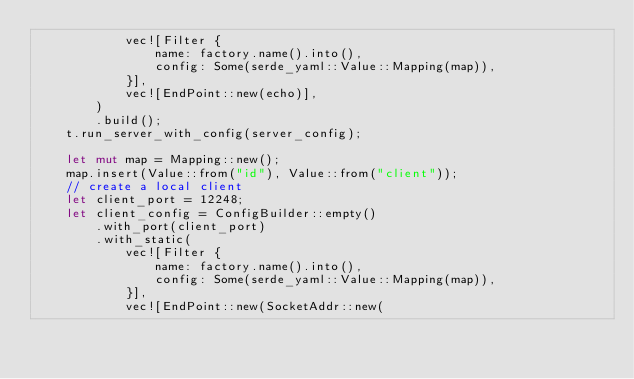<code> <loc_0><loc_0><loc_500><loc_500><_Rust_>            vec![Filter {
                name: factory.name().into(),
                config: Some(serde_yaml::Value::Mapping(map)),
            }],
            vec![EndPoint::new(echo)],
        )
        .build();
    t.run_server_with_config(server_config);

    let mut map = Mapping::new();
    map.insert(Value::from("id"), Value::from("client"));
    // create a local client
    let client_port = 12248;
    let client_config = ConfigBuilder::empty()
        .with_port(client_port)
        .with_static(
            vec![Filter {
                name: factory.name().into(),
                config: Some(serde_yaml::Value::Mapping(map)),
            }],
            vec![EndPoint::new(SocketAddr::new(</code> 